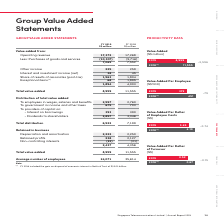According to Singapore Telecommunications's financial document, What was included in the exceptional items in FY2018? FY 2018 included the gain on disposal of economic interest in NetLink Trust of S$2.03 billion.. The document states: "Note: (1) FY 2018 included the gain on disposal of economic interest in NetLink Trust of S$2.03 billion...." Also, What was the value of retained profits in FY 2018? According to the financial document, 2,127 (in millions). The relevant text states: "and amortisation 2,222 2,250 Retained proﬁts 238 2,127 Non-controlling interests (23) (21) 2,437 4,356..." Also, What are the 2 components for providers of capital? The document shows two values: Interest on borrowings and Dividends to shareholders. From the document: "other taxes 675 703 To providers of capital on: - Interest on borrowings 393 390 - Dividends to shareholders 2,857 3,346 of capital on: - Interest on ..." Additionally, Which year was there a higher average number of employees? According to the financial document, 2018. The relevant text states: "FY 2019 S$ million FY 2018 S$ million..." Additionally, Which year had a higher total value added figure? According to the financial document, 2018. The relevant text states: "FY 2019 S$ million FY 2018 S$ million..." Also, How many components are there under the section "retained in business"? Counting the relevant items in the document: Depreciation and amortisation, Retained profits, Non-controlling interests, I find 3 instances. The key data points involved are: Depreciation and amortisation, Non-controlling interests, Retained profits. 